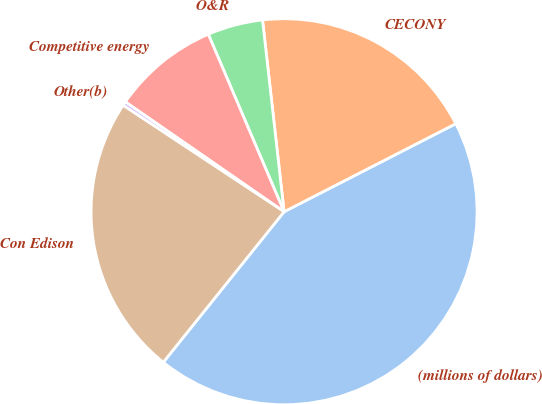Convert chart to OTSL. <chart><loc_0><loc_0><loc_500><loc_500><pie_chart><fcel>(millions of dollars)<fcel>CECONY<fcel>O&R<fcel>Competitive energy<fcel>Other(b)<fcel>Con Edison<nl><fcel>43.3%<fcel>19.24%<fcel>4.64%<fcel>8.94%<fcel>0.34%<fcel>23.53%<nl></chart> 